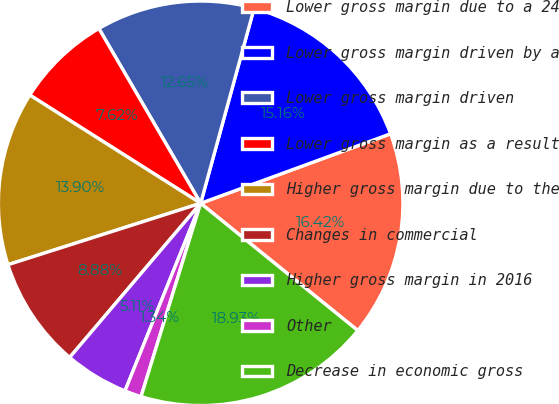Convert chart. <chart><loc_0><loc_0><loc_500><loc_500><pie_chart><fcel>Lower gross margin due to a 24<fcel>Lower gross margin driven by a<fcel>Lower gross margin driven<fcel>Lower gross margin as a result<fcel>Higher gross margin due to the<fcel>Changes in commercial<fcel>Higher gross margin in 2016<fcel>Other<fcel>Decrease in economic gross<nl><fcel>16.42%<fcel>15.16%<fcel>12.65%<fcel>7.62%<fcel>13.9%<fcel>8.88%<fcel>5.11%<fcel>1.34%<fcel>18.93%<nl></chart> 